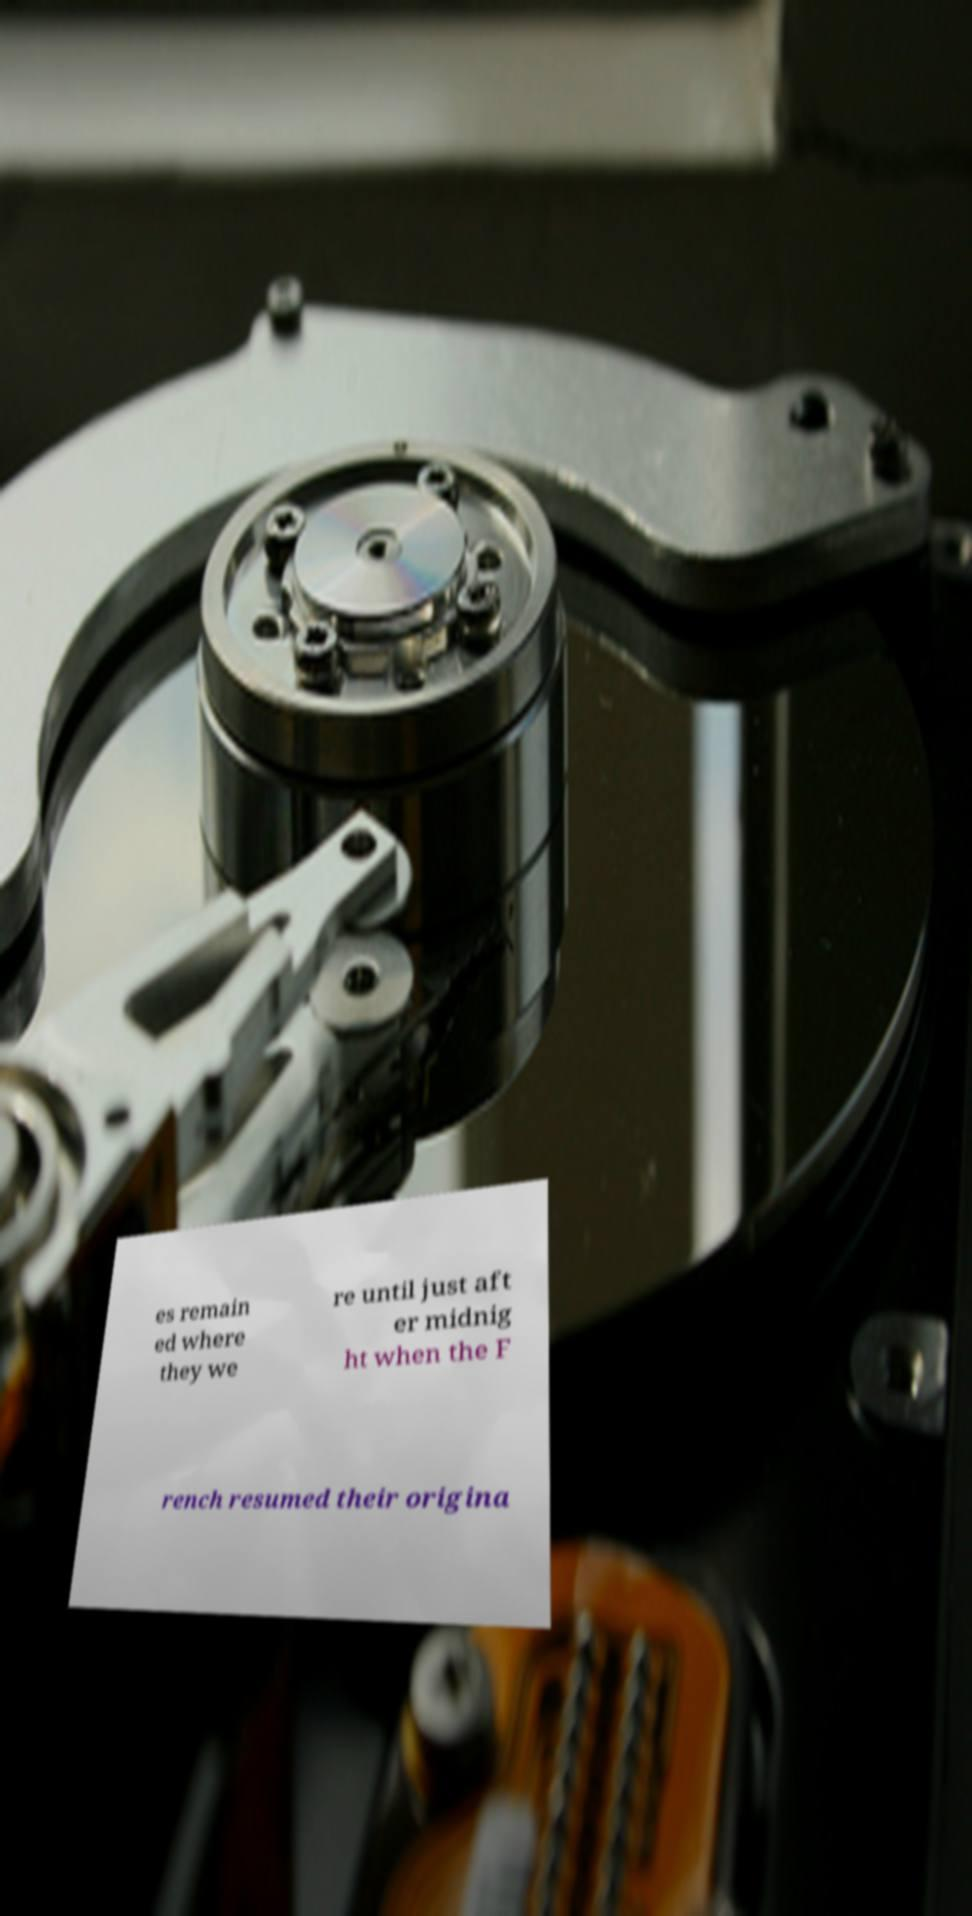What messages or text are displayed in this image? I need them in a readable, typed format. es remain ed where they we re until just aft er midnig ht when the F rench resumed their origina 